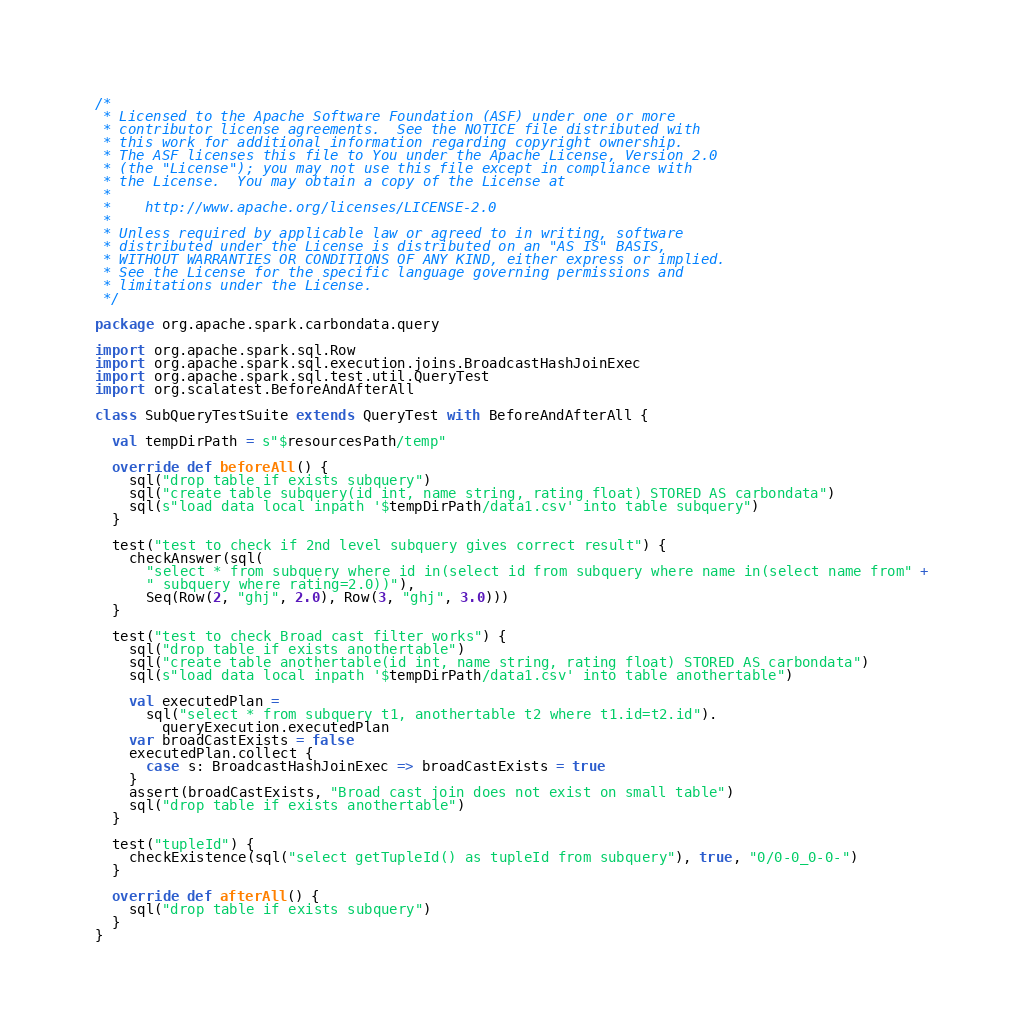Convert code to text. <code><loc_0><loc_0><loc_500><loc_500><_Scala_>/*
 * Licensed to the Apache Software Foundation (ASF) under one or more
 * contributor license agreements.  See the NOTICE file distributed with
 * this work for additional information regarding copyright ownership.
 * The ASF licenses this file to You under the Apache License, Version 2.0
 * (the "License"); you may not use this file except in compliance with
 * the License.  You may obtain a copy of the License at
 *
 *    http://www.apache.org/licenses/LICENSE-2.0
 *
 * Unless required by applicable law or agreed to in writing, software
 * distributed under the License is distributed on an "AS IS" BASIS,
 * WITHOUT WARRANTIES OR CONDITIONS OF ANY KIND, either express or implied.
 * See the License for the specific language governing permissions and
 * limitations under the License.
 */

package org.apache.spark.carbondata.query

import org.apache.spark.sql.Row
import org.apache.spark.sql.execution.joins.BroadcastHashJoinExec
import org.apache.spark.sql.test.util.QueryTest
import org.scalatest.BeforeAndAfterAll

class SubQueryTestSuite extends QueryTest with BeforeAndAfterAll {

  val tempDirPath = s"$resourcesPath/temp"

  override def beforeAll() {
    sql("drop table if exists subquery")
    sql("create table subquery(id int, name string, rating float) STORED AS carbondata")
    sql(s"load data local inpath '$tempDirPath/data1.csv' into table subquery")
  }

  test("test to check if 2nd level subquery gives correct result") {
    checkAnswer(sql(
      "select * from subquery where id in(select id from subquery where name in(select name from" +
      " subquery where rating=2.0))"),
      Seq(Row(2, "ghj", 2.0), Row(3, "ghj", 3.0)))
  }

  test("test to check Broad cast filter works") {
    sql("drop table if exists anothertable")
    sql("create table anothertable(id int, name string, rating float) STORED AS carbondata")
    sql(s"load data local inpath '$tempDirPath/data1.csv' into table anothertable")

    val executedPlan =
      sql("select * from subquery t1, anothertable t2 where t1.id=t2.id").
        queryExecution.executedPlan
    var broadCastExists = false
    executedPlan.collect {
      case s: BroadcastHashJoinExec => broadCastExists = true
    }
    assert(broadCastExists, "Broad cast join does not exist on small table")
    sql("drop table if exists anothertable")
  }

  test("tupleId") {
    checkExistence(sql("select getTupleId() as tupleId from subquery"), true, "0/0-0_0-0-")
  }

  override def afterAll() {
    sql("drop table if exists subquery")
  }
}
</code> 